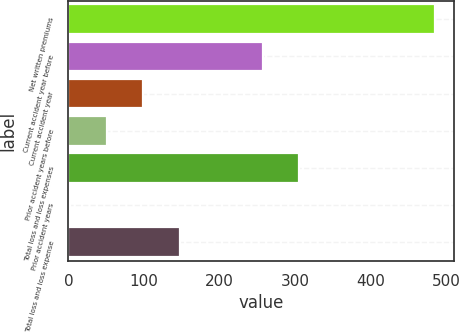Convert chart. <chart><loc_0><loc_0><loc_500><loc_500><bar_chart><fcel>Net written premiums<fcel>Current accident year before<fcel>Current accident year<fcel>Prior accident years before<fcel>Total loss and loss expenses<fcel>Prior accident years<fcel>Total loss and loss expense<nl><fcel>485<fcel>257<fcel>98.76<fcel>50.48<fcel>305.28<fcel>2.2<fcel>147.04<nl></chart> 